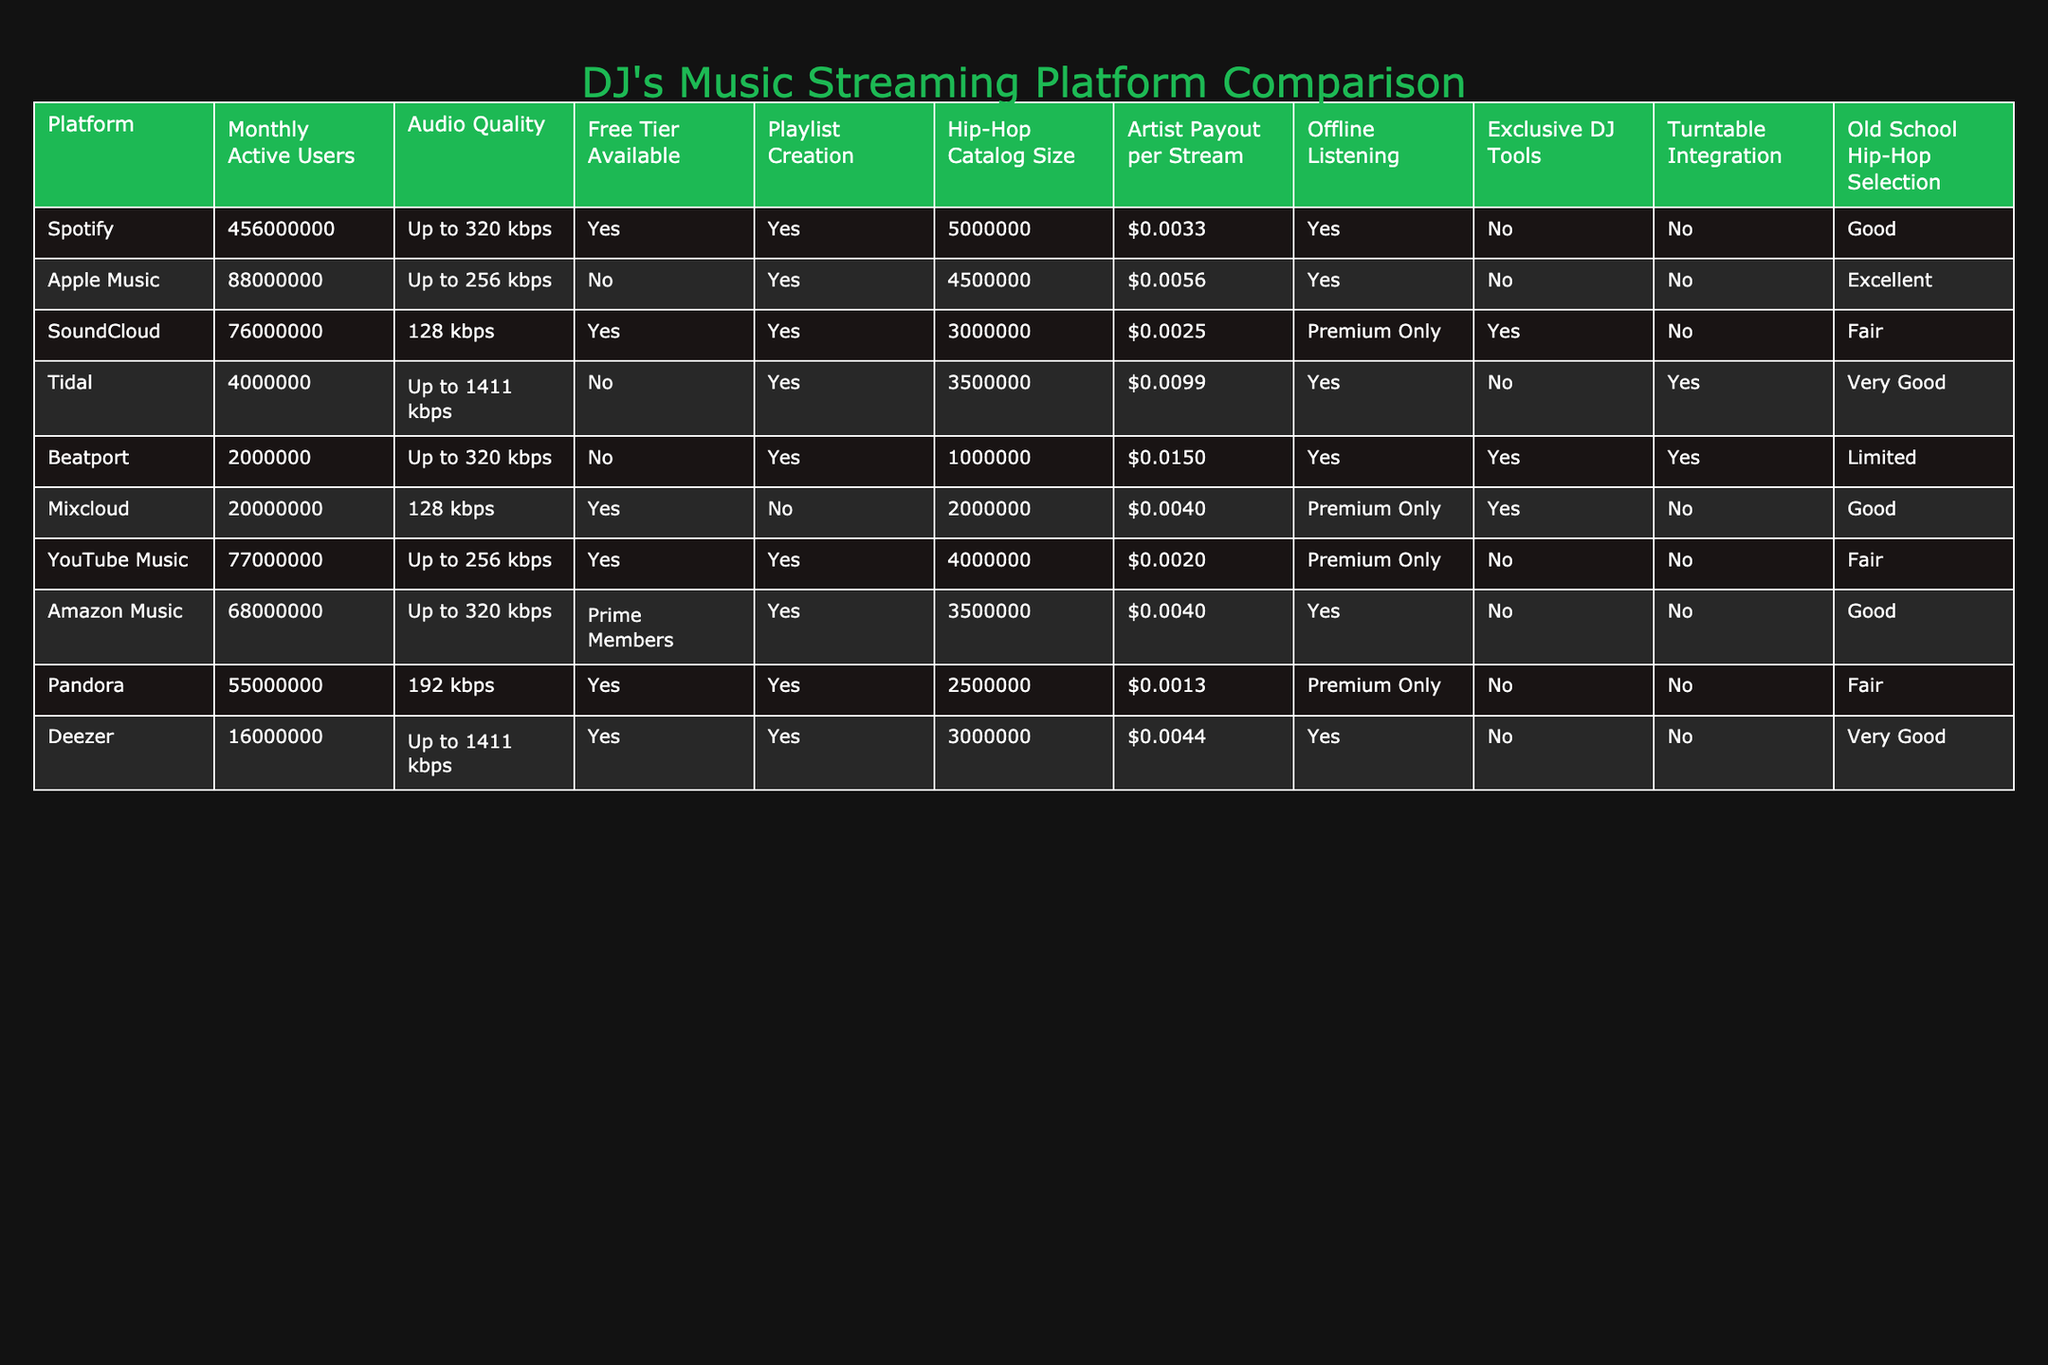What is the monthly active user count for Spotify? The table shows the "Monthly Active Users" for each platform, and for Spotify, it specifically states the count is 456,000,000.
Answer: 456,000,000 Which platform has the highest artist payout per stream? By examining the "Artist Payout per Stream" column, Tidal has the highest payout at $0.0099, while the others are lower.
Answer: Tidal Is there a free tier available for Apple Music? The "Free Tier Available" column indicates "No" for Apple Music, meaning it does not offer a free option.
Answer: No What is the average audio quality (in kbps) for the platforms that offer offline listening? The platforms offering offline listening are Spotify (320), Tidal (1411), and Deezer (1411). The average is (320 + 1411 + 1411) / 3 = 747.33 kbps.
Answer: 747.33 kbps Does Beatport have any exclusive DJ tools? According to the "Exclusive DJ Tools" column, Beatport is marked "Yes," indicating that it does provide exclusive DJ tools.
Answer: Yes Which platform has the largest hip-hop catalog size? Checking the "Hip-Hop Catalog Size" column, Spotify has the largest catalog at 5,000,000, more than any other platform listed.
Answer: Spotify Compare the total hip-hop catalog size between SoundCloud and YouTube Music. SoundCloud has a hip-hop catalog size of 3,000,000 and YouTube Music has 4,000,000. The combined total is 3,000,000 + 4,000,000 = 7,000,000.
Answer: 7,000,000 How many platforms have a monthly active user count lower than 20 million? By looking at the "Monthly Active Users" column, only Beatport and Mixcloud have user counts lower than 20 million, which indicates there are 2 such platforms.
Answer: 2 Which platform offers the best old-school hip-hop selection? Referring to the "Old School Hip-Hop Selection" column, Apple Music is rated "Excellent," indicating it has the best old-school selection.
Answer: Apple Music Is the audio quality for Pandora higher than that of Amazon Music? The audio quality for Pandora is 192 kbps and for Amazon Music it is up to 320 kbps. Since 320 kbps is higher than 192 kbps, the answer is "No."
Answer: No 